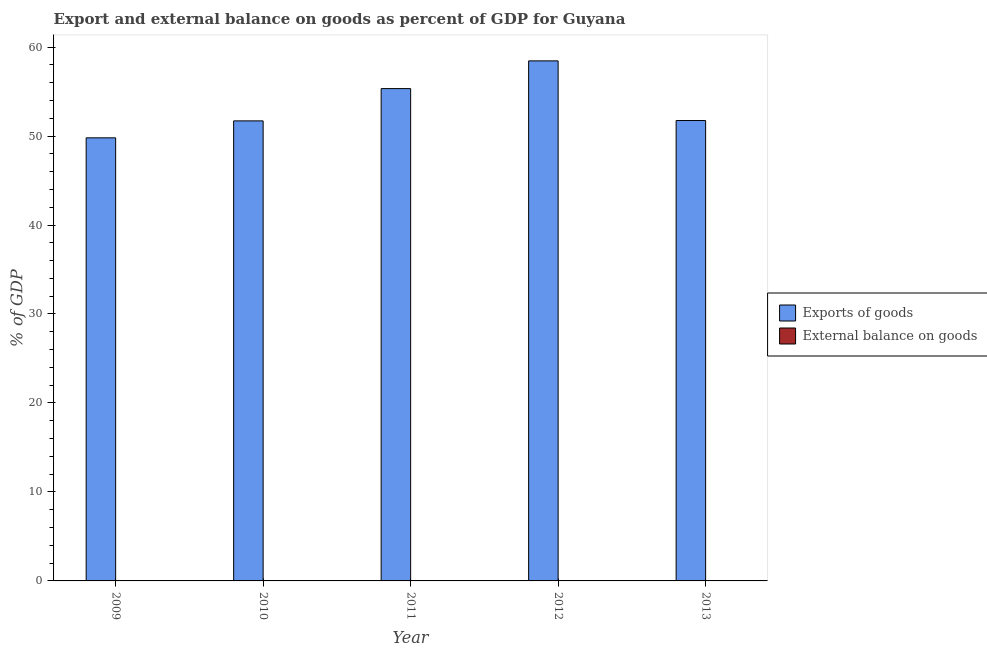How many different coloured bars are there?
Provide a succinct answer. 1. How many bars are there on the 5th tick from the left?
Provide a short and direct response. 1. In how many cases, is the number of bars for a given year not equal to the number of legend labels?
Ensure brevity in your answer.  5. What is the export of goods as percentage of gdp in 2013?
Offer a very short reply. 51.74. Across all years, what is the maximum export of goods as percentage of gdp?
Offer a terse response. 58.45. Across all years, what is the minimum export of goods as percentage of gdp?
Ensure brevity in your answer.  49.8. What is the total external balance on goods as percentage of gdp in the graph?
Make the answer very short. 0. What is the difference between the export of goods as percentage of gdp in 2009 and that in 2013?
Your response must be concise. -1.95. What is the difference between the export of goods as percentage of gdp in 2010 and the external balance on goods as percentage of gdp in 2009?
Provide a short and direct response. 1.91. What is the average export of goods as percentage of gdp per year?
Provide a succinct answer. 53.4. In how many years, is the export of goods as percentage of gdp greater than 46 %?
Offer a terse response. 5. What is the ratio of the export of goods as percentage of gdp in 2011 to that in 2012?
Make the answer very short. 0.95. What is the difference between the highest and the second highest export of goods as percentage of gdp?
Your response must be concise. 3.12. What is the difference between the highest and the lowest export of goods as percentage of gdp?
Ensure brevity in your answer.  8.65. Is the sum of the export of goods as percentage of gdp in 2009 and 2012 greater than the maximum external balance on goods as percentage of gdp across all years?
Your answer should be compact. Yes. How many bars are there?
Provide a short and direct response. 5. Are all the bars in the graph horizontal?
Your answer should be very brief. No. What is the difference between two consecutive major ticks on the Y-axis?
Give a very brief answer. 10. Are the values on the major ticks of Y-axis written in scientific E-notation?
Keep it short and to the point. No. Does the graph contain grids?
Give a very brief answer. No. What is the title of the graph?
Keep it short and to the point. Export and external balance on goods as percent of GDP for Guyana. What is the label or title of the X-axis?
Keep it short and to the point. Year. What is the label or title of the Y-axis?
Keep it short and to the point. % of GDP. What is the % of GDP of Exports of goods in 2009?
Provide a short and direct response. 49.8. What is the % of GDP in Exports of goods in 2010?
Make the answer very short. 51.7. What is the % of GDP of Exports of goods in 2011?
Provide a short and direct response. 55.33. What is the % of GDP in Exports of goods in 2012?
Your response must be concise. 58.45. What is the % of GDP of Exports of goods in 2013?
Provide a succinct answer. 51.74. What is the % of GDP in External balance on goods in 2013?
Ensure brevity in your answer.  0. Across all years, what is the maximum % of GDP in Exports of goods?
Your answer should be very brief. 58.45. Across all years, what is the minimum % of GDP of Exports of goods?
Your answer should be very brief. 49.8. What is the total % of GDP in Exports of goods in the graph?
Provide a succinct answer. 267.01. What is the total % of GDP in External balance on goods in the graph?
Provide a succinct answer. 0. What is the difference between the % of GDP of Exports of goods in 2009 and that in 2010?
Offer a very short reply. -1.91. What is the difference between the % of GDP of Exports of goods in 2009 and that in 2011?
Make the answer very short. -5.53. What is the difference between the % of GDP of Exports of goods in 2009 and that in 2012?
Provide a short and direct response. -8.65. What is the difference between the % of GDP in Exports of goods in 2009 and that in 2013?
Your answer should be very brief. -1.95. What is the difference between the % of GDP of Exports of goods in 2010 and that in 2011?
Keep it short and to the point. -3.63. What is the difference between the % of GDP of Exports of goods in 2010 and that in 2012?
Make the answer very short. -6.74. What is the difference between the % of GDP in Exports of goods in 2010 and that in 2013?
Provide a short and direct response. -0.04. What is the difference between the % of GDP of Exports of goods in 2011 and that in 2012?
Give a very brief answer. -3.12. What is the difference between the % of GDP in Exports of goods in 2011 and that in 2013?
Your answer should be compact. 3.59. What is the difference between the % of GDP in Exports of goods in 2012 and that in 2013?
Provide a short and direct response. 6.7. What is the average % of GDP of Exports of goods per year?
Make the answer very short. 53.4. What is the average % of GDP in External balance on goods per year?
Give a very brief answer. 0. What is the ratio of the % of GDP in Exports of goods in 2009 to that in 2010?
Provide a succinct answer. 0.96. What is the ratio of the % of GDP in Exports of goods in 2009 to that in 2012?
Provide a short and direct response. 0.85. What is the ratio of the % of GDP in Exports of goods in 2009 to that in 2013?
Provide a succinct answer. 0.96. What is the ratio of the % of GDP of Exports of goods in 2010 to that in 2011?
Your answer should be very brief. 0.93. What is the ratio of the % of GDP in Exports of goods in 2010 to that in 2012?
Offer a very short reply. 0.88. What is the ratio of the % of GDP in Exports of goods in 2010 to that in 2013?
Give a very brief answer. 1. What is the ratio of the % of GDP in Exports of goods in 2011 to that in 2012?
Offer a terse response. 0.95. What is the ratio of the % of GDP in Exports of goods in 2011 to that in 2013?
Your response must be concise. 1.07. What is the ratio of the % of GDP of Exports of goods in 2012 to that in 2013?
Your answer should be compact. 1.13. What is the difference between the highest and the second highest % of GDP in Exports of goods?
Ensure brevity in your answer.  3.12. What is the difference between the highest and the lowest % of GDP in Exports of goods?
Provide a short and direct response. 8.65. 